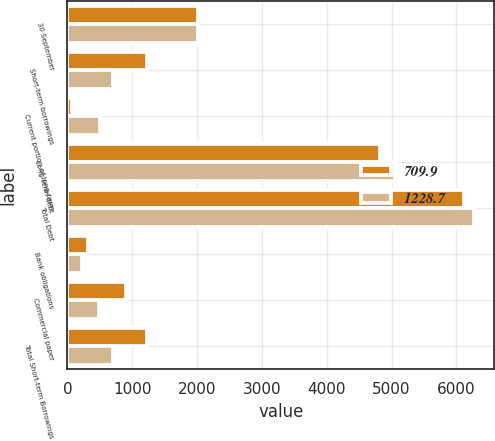Convert chart. <chart><loc_0><loc_0><loc_500><loc_500><stacked_bar_chart><ecel><fcel>30 September<fcel>Short-term borrowings<fcel>Current portion of long-term<fcel>Long-term debt<fcel>Total Debt<fcel>Bank obligations<fcel>Commercial paper<fcel>Total Short-term Borrowings<nl><fcel>709.9<fcel>2014<fcel>1228.7<fcel>65.3<fcel>4824.5<fcel>6118.5<fcel>320.7<fcel>908<fcel>1228.7<nl><fcel>1228.7<fcel>2013<fcel>709.9<fcel>507.4<fcel>5056.3<fcel>6273.6<fcel>218.9<fcel>491<fcel>709.9<nl></chart> 